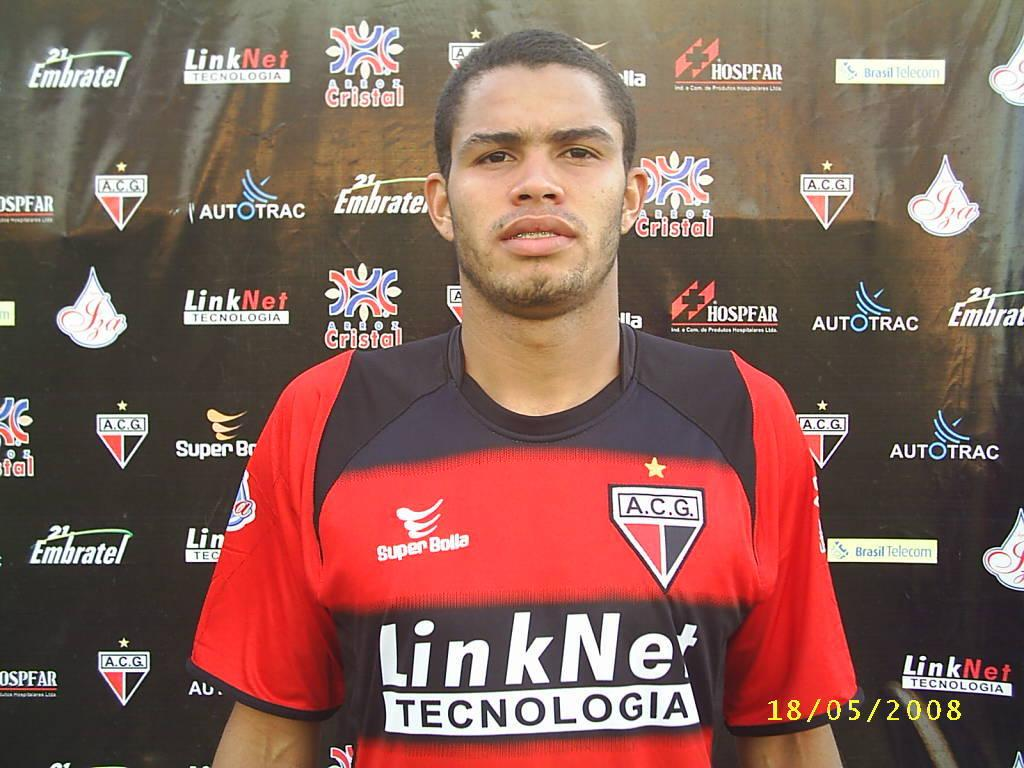<image>
Summarize the visual content of the image. The sponsor of the jersey was the LinkNet company. 